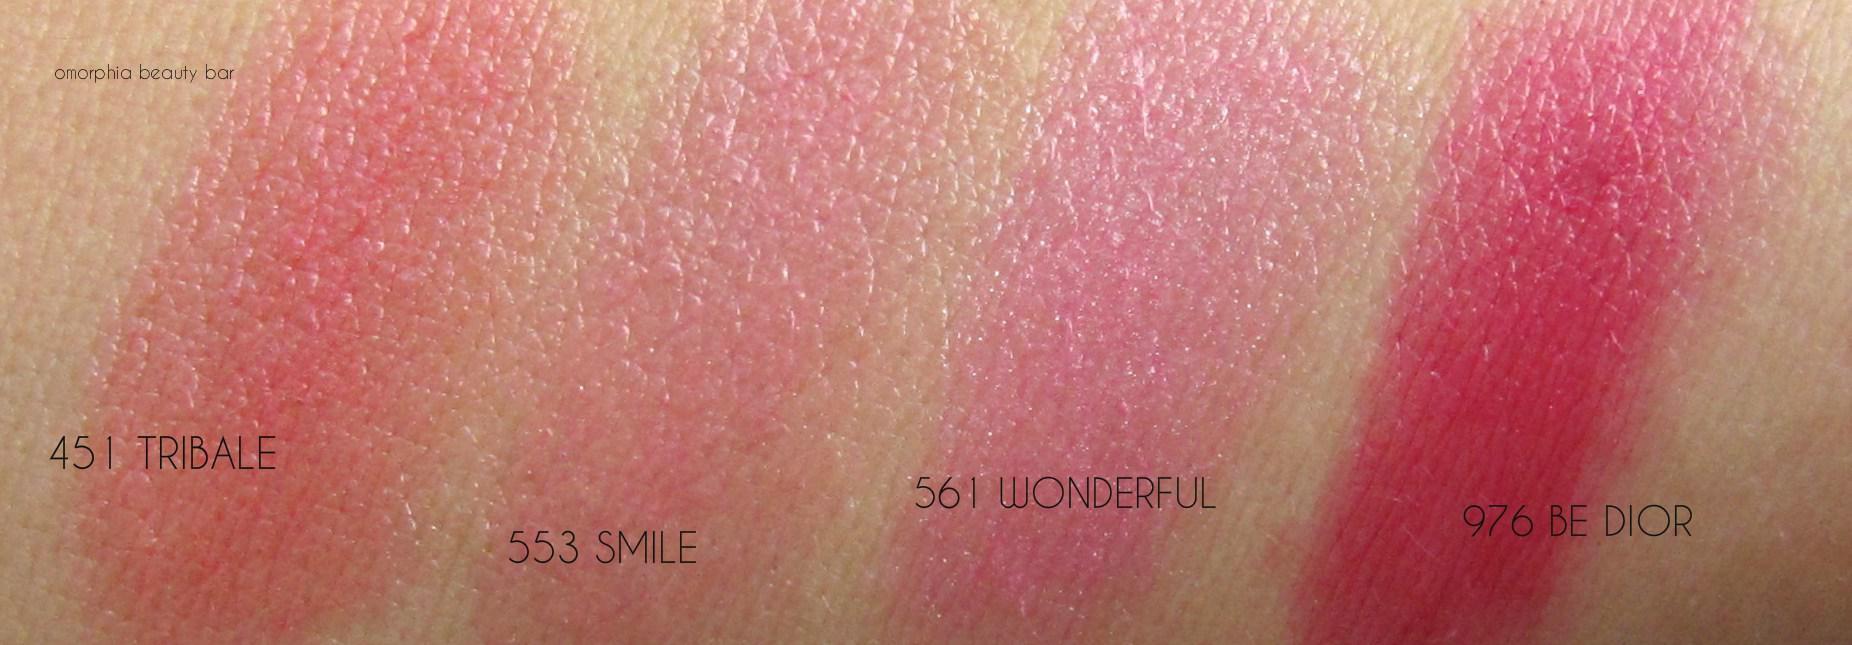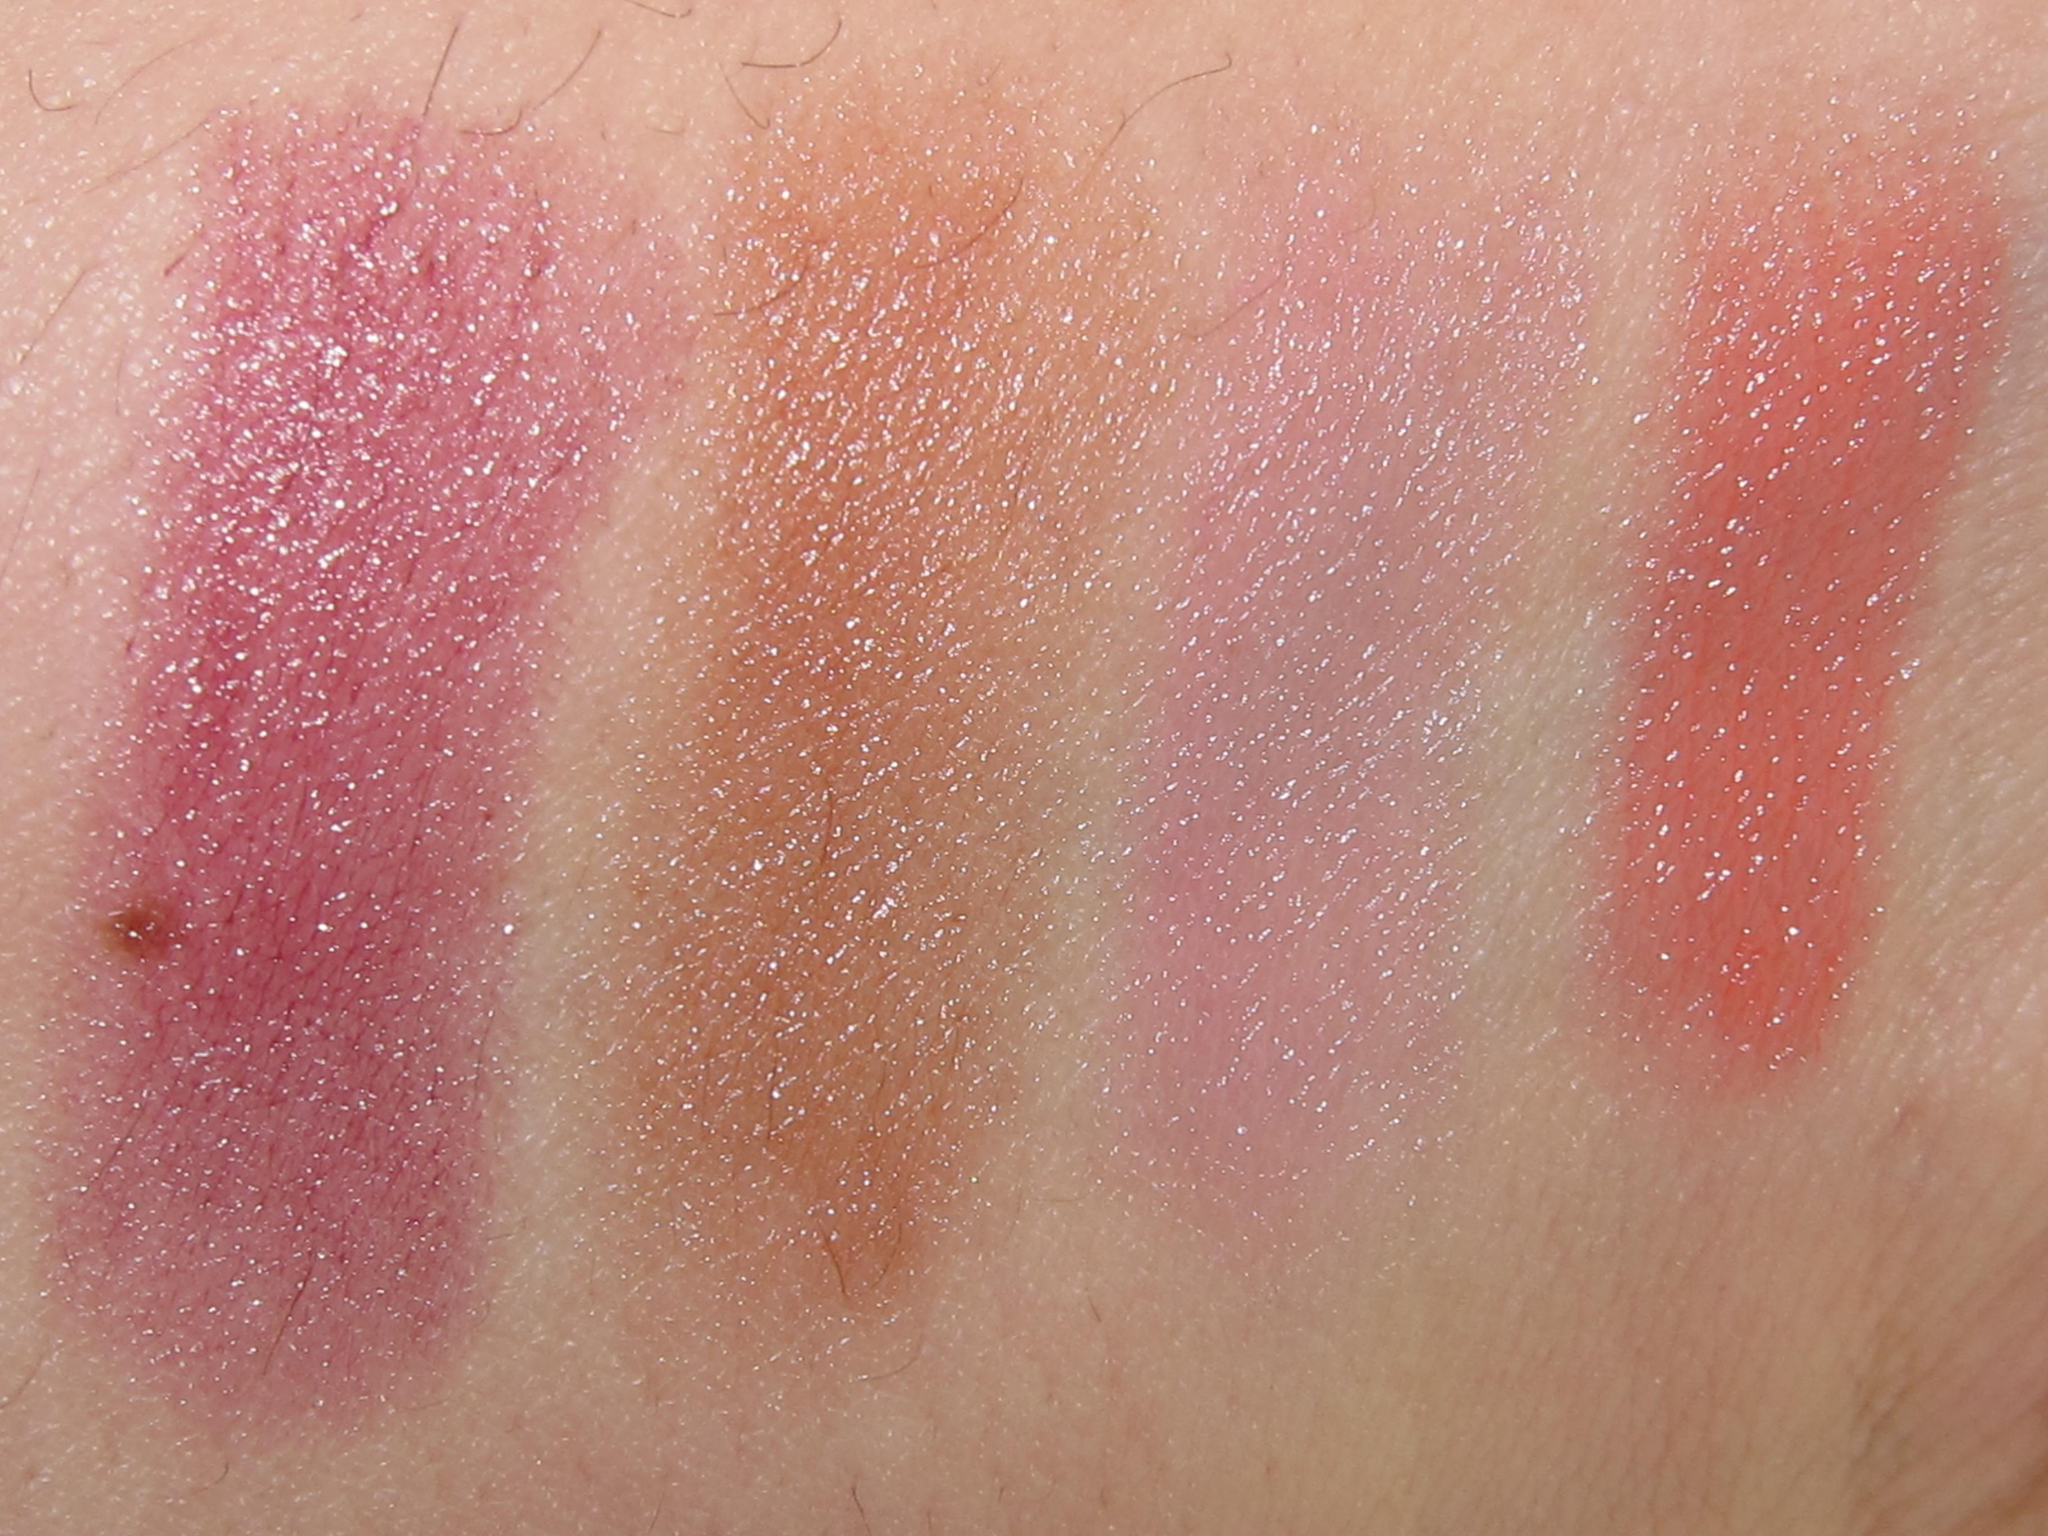The first image is the image on the left, the second image is the image on the right. Examine the images to the left and right. Is the description "Atleast 1 pair of lips can be seen." accurate? Answer yes or no. No. The first image is the image on the left, the second image is the image on the right. Given the left and right images, does the statement "At least one of the images shows a woman's lips." hold true? Answer yes or no. No. 